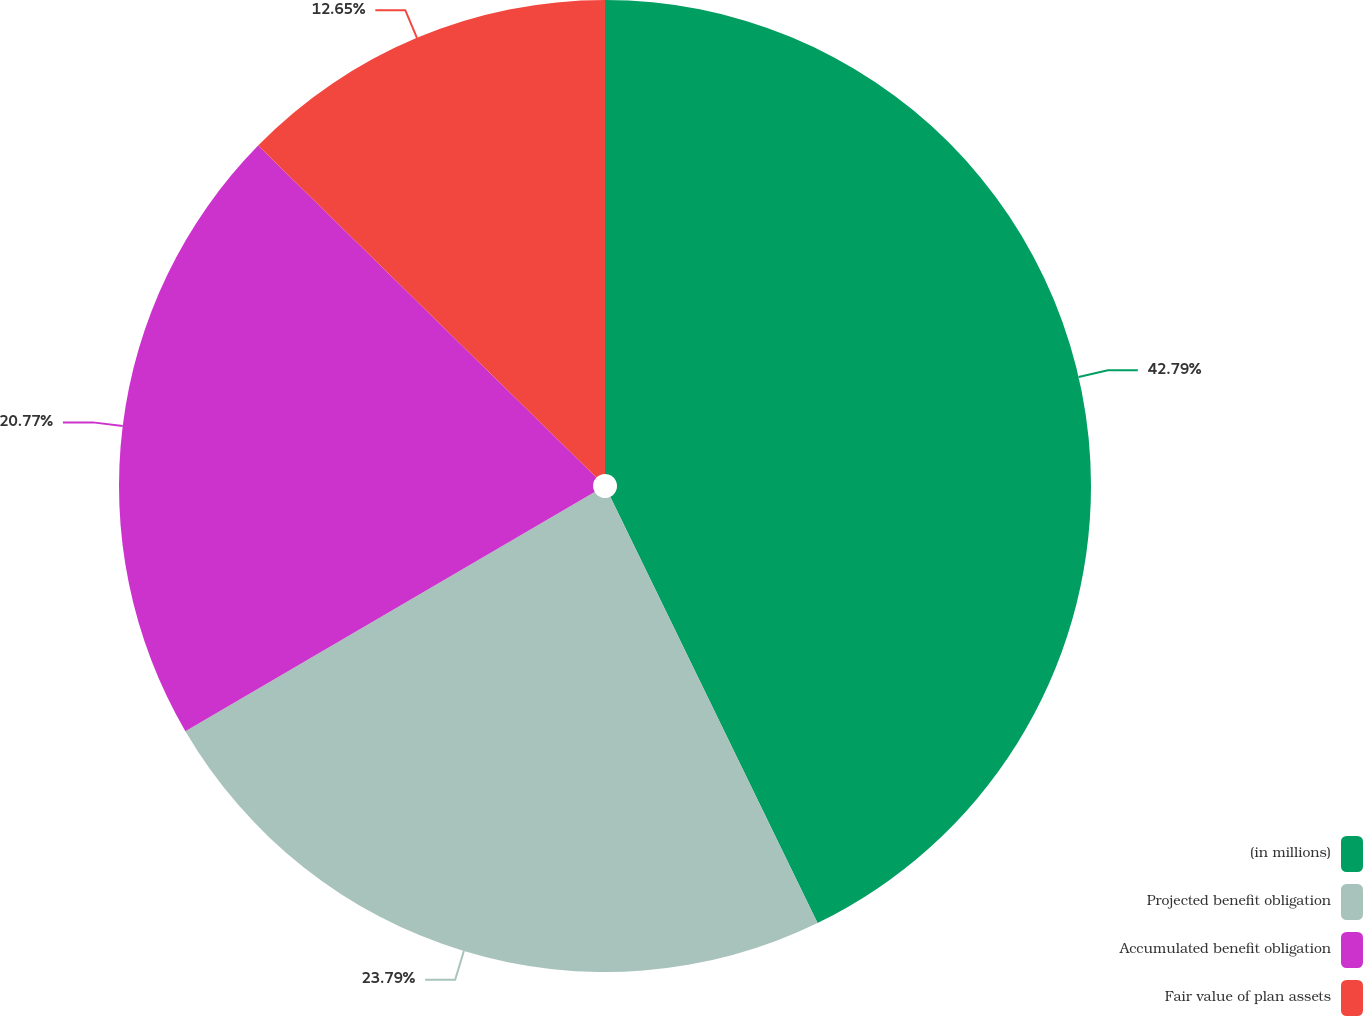Convert chart. <chart><loc_0><loc_0><loc_500><loc_500><pie_chart><fcel>(in millions)<fcel>Projected benefit obligation<fcel>Accumulated benefit obligation<fcel>Fair value of plan assets<nl><fcel>42.8%<fcel>23.79%<fcel>20.77%<fcel>12.65%<nl></chart> 